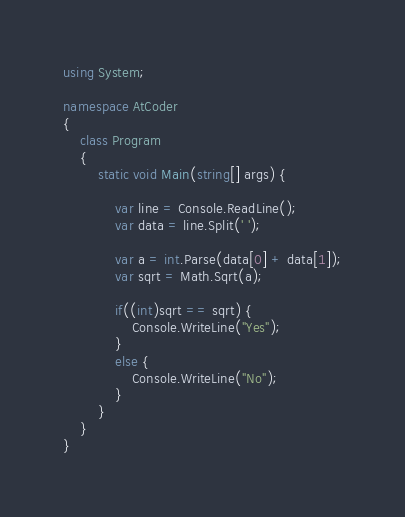<code> <loc_0><loc_0><loc_500><loc_500><_C#_>using System;

namespace AtCoder
{
    class Program
    {
        static void Main(string[] args) {

            var line = Console.ReadLine();
            var data = line.Split(' ');

            var a = int.Parse(data[0] + data[1]);
            var sqrt = Math.Sqrt(a);

            if((int)sqrt == sqrt) {
                Console.WriteLine("Yes");
            }
            else {
                Console.WriteLine("No");
            }
        }
    }
}
</code> 